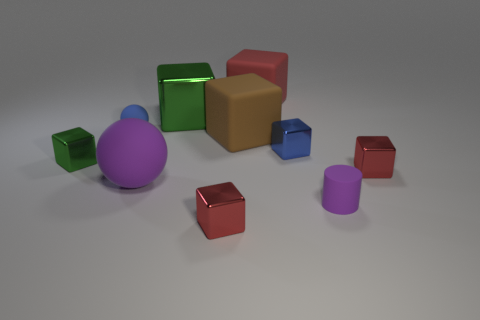There is a rubber cube that is on the left side of the large red matte cube; what color is it?
Provide a succinct answer. Brown. Do the green object that is in front of the brown thing and the big metal object have the same size?
Your response must be concise. No. Is the number of metallic balls less than the number of green metal blocks?
Give a very brief answer. Yes. The object that is the same color as the tiny sphere is what shape?
Your answer should be compact. Cube. How many tiny purple cylinders are on the left side of the big red rubber object?
Make the answer very short. 0. Do the big purple rubber object and the blue matte object have the same shape?
Your response must be concise. Yes. How many large rubber objects are both behind the blue shiny object and in front of the small blue block?
Provide a succinct answer. 0. How many objects are either metal cubes or green blocks that are in front of the big green metallic block?
Provide a short and direct response. 5. Is the number of purple rubber balls greater than the number of blocks?
Give a very brief answer. No. There is a red metallic thing on the right side of the big brown matte thing; what is its shape?
Make the answer very short. Cube. 